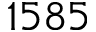Convert formula to latex. <formula><loc_0><loc_0><loc_500><loc_500>1 5 8 5</formula> 